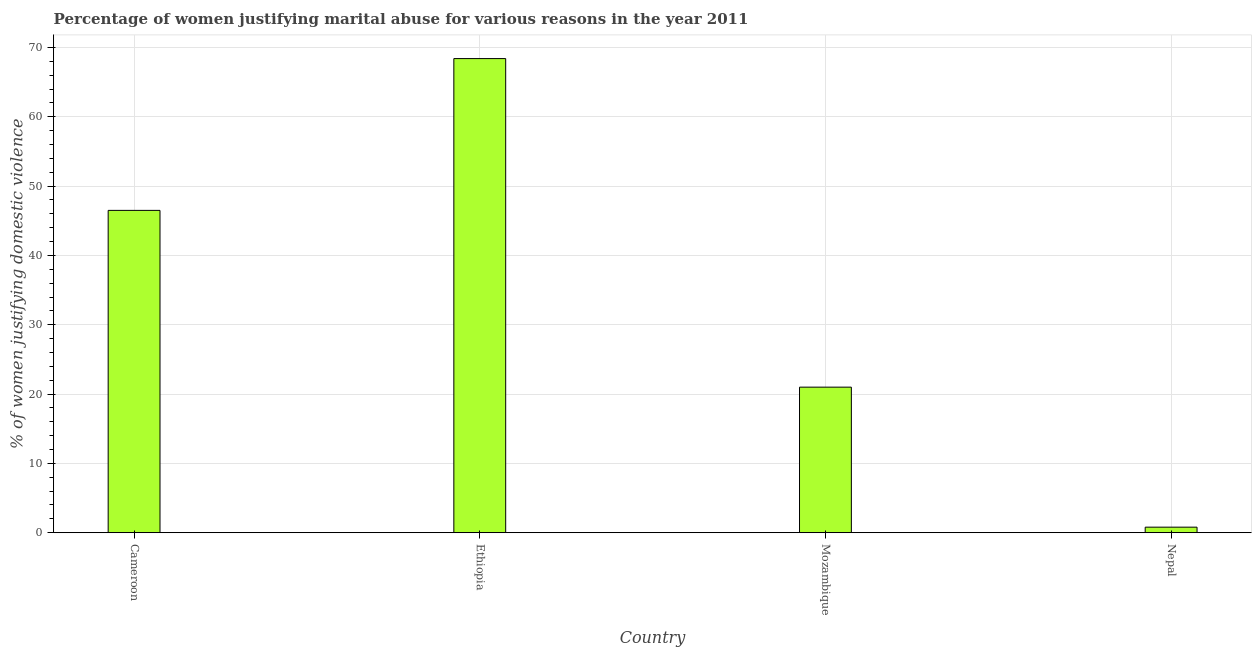Does the graph contain any zero values?
Your answer should be very brief. No. What is the title of the graph?
Keep it short and to the point. Percentage of women justifying marital abuse for various reasons in the year 2011. What is the label or title of the Y-axis?
Keep it short and to the point. % of women justifying domestic violence. What is the percentage of women justifying marital abuse in Nepal?
Keep it short and to the point. 0.8. Across all countries, what is the maximum percentage of women justifying marital abuse?
Offer a terse response. 68.4. In which country was the percentage of women justifying marital abuse maximum?
Provide a short and direct response. Ethiopia. In which country was the percentage of women justifying marital abuse minimum?
Make the answer very short. Nepal. What is the sum of the percentage of women justifying marital abuse?
Offer a very short reply. 136.7. What is the difference between the percentage of women justifying marital abuse in Ethiopia and Nepal?
Give a very brief answer. 67.6. What is the average percentage of women justifying marital abuse per country?
Make the answer very short. 34.17. What is the median percentage of women justifying marital abuse?
Make the answer very short. 33.75. What is the ratio of the percentage of women justifying marital abuse in Ethiopia to that in Mozambique?
Offer a very short reply. 3.26. Is the percentage of women justifying marital abuse in Cameroon less than that in Mozambique?
Offer a terse response. No. Is the difference between the percentage of women justifying marital abuse in Cameroon and Ethiopia greater than the difference between any two countries?
Provide a short and direct response. No. What is the difference between the highest and the second highest percentage of women justifying marital abuse?
Offer a terse response. 21.9. What is the difference between the highest and the lowest percentage of women justifying marital abuse?
Your answer should be very brief. 67.6. In how many countries, is the percentage of women justifying marital abuse greater than the average percentage of women justifying marital abuse taken over all countries?
Your answer should be very brief. 2. How many countries are there in the graph?
Ensure brevity in your answer.  4. What is the difference between two consecutive major ticks on the Y-axis?
Offer a very short reply. 10. Are the values on the major ticks of Y-axis written in scientific E-notation?
Your answer should be compact. No. What is the % of women justifying domestic violence in Cameroon?
Provide a short and direct response. 46.5. What is the % of women justifying domestic violence of Ethiopia?
Ensure brevity in your answer.  68.4. What is the % of women justifying domestic violence of Mozambique?
Offer a very short reply. 21. What is the difference between the % of women justifying domestic violence in Cameroon and Ethiopia?
Make the answer very short. -21.9. What is the difference between the % of women justifying domestic violence in Cameroon and Mozambique?
Provide a succinct answer. 25.5. What is the difference between the % of women justifying domestic violence in Cameroon and Nepal?
Your answer should be very brief. 45.7. What is the difference between the % of women justifying domestic violence in Ethiopia and Mozambique?
Give a very brief answer. 47.4. What is the difference between the % of women justifying domestic violence in Ethiopia and Nepal?
Your answer should be compact. 67.6. What is the difference between the % of women justifying domestic violence in Mozambique and Nepal?
Make the answer very short. 20.2. What is the ratio of the % of women justifying domestic violence in Cameroon to that in Ethiopia?
Provide a succinct answer. 0.68. What is the ratio of the % of women justifying domestic violence in Cameroon to that in Mozambique?
Your answer should be compact. 2.21. What is the ratio of the % of women justifying domestic violence in Cameroon to that in Nepal?
Give a very brief answer. 58.12. What is the ratio of the % of women justifying domestic violence in Ethiopia to that in Mozambique?
Provide a succinct answer. 3.26. What is the ratio of the % of women justifying domestic violence in Ethiopia to that in Nepal?
Offer a very short reply. 85.5. What is the ratio of the % of women justifying domestic violence in Mozambique to that in Nepal?
Your response must be concise. 26.25. 